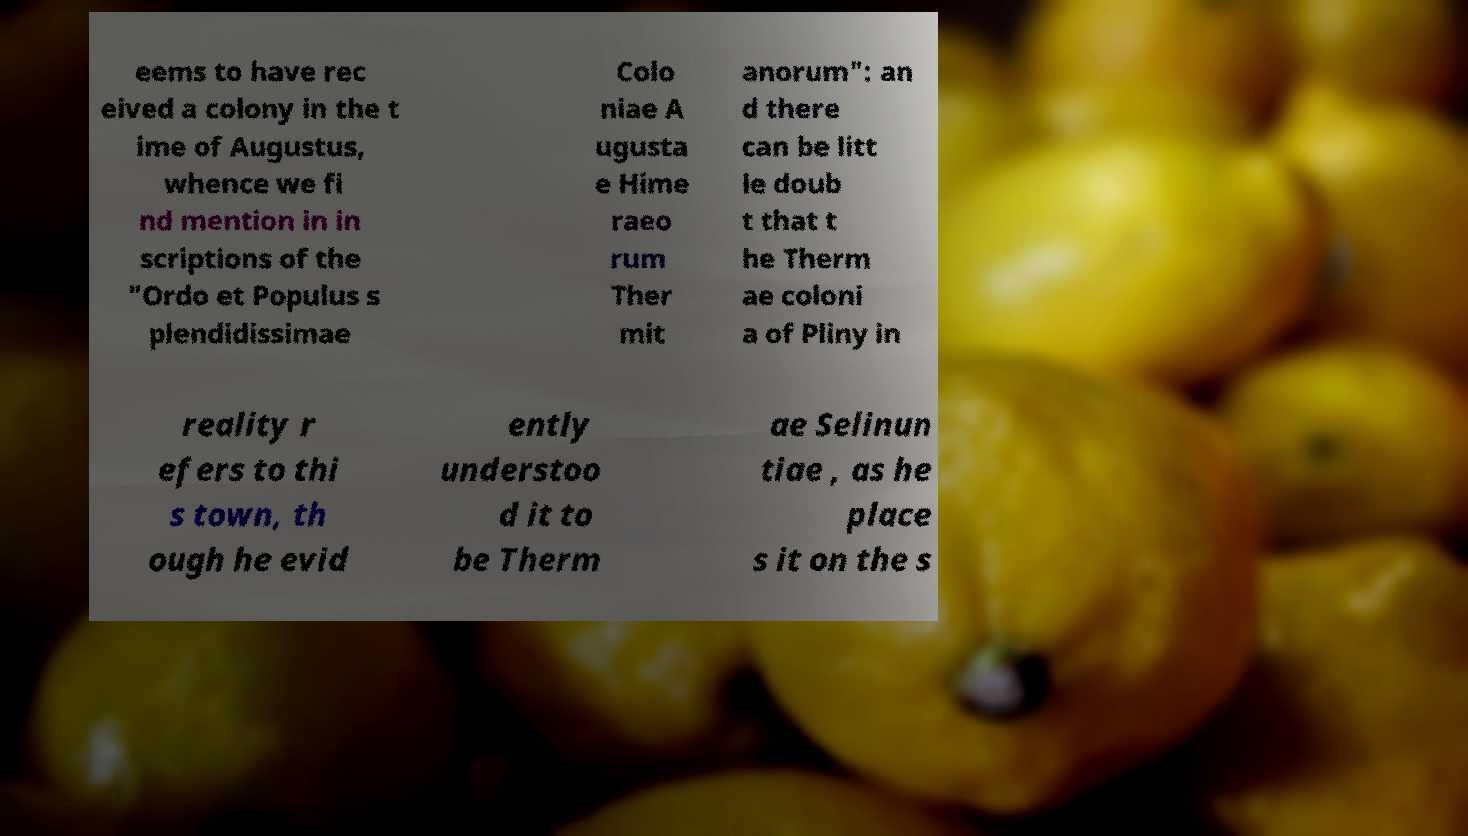For documentation purposes, I need the text within this image transcribed. Could you provide that? eems to have rec eived a colony in the t ime of Augustus, whence we fi nd mention in in scriptions of the "Ordo et Populus s plendidissimae Colo niae A ugusta e Hime raeo rum Ther mit anorum": an d there can be litt le doub t that t he Therm ae coloni a of Pliny in reality r efers to thi s town, th ough he evid ently understoo d it to be Therm ae Selinun tiae , as he place s it on the s 